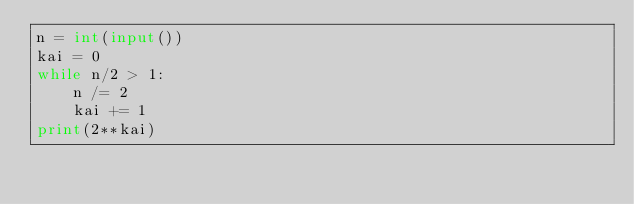Convert code to text. <code><loc_0><loc_0><loc_500><loc_500><_Python_>n = int(input())
kai = 0
while n/2 > 1:
    n /= 2
    kai += 1
print(2**kai)
</code> 